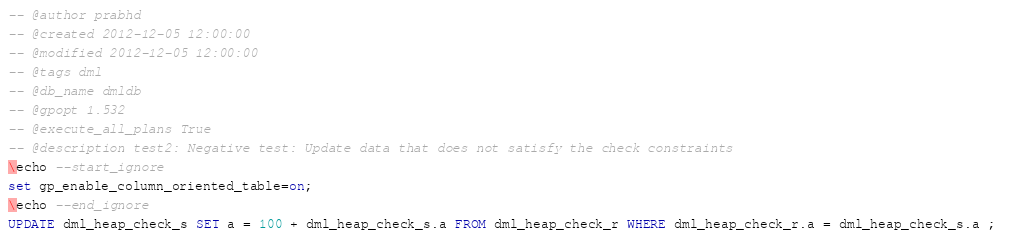Convert code to text. <code><loc_0><loc_0><loc_500><loc_500><_SQL_>-- @author prabhd 
-- @created 2012-12-05 12:00:00 
-- @modified 2012-12-05 12:00:00 
-- @tags dml 
-- @db_name dmldb
-- @gpopt 1.532
-- @execute_all_plans True
-- @description test2: Negative test: Update data that does not satisfy the check constraints 
\echo --start_ignore
set gp_enable_column_oriented_table=on;
\echo --end_ignore
UPDATE dml_heap_check_s SET a = 100 + dml_heap_check_s.a FROM dml_heap_check_r WHERE dml_heap_check_r.a = dml_heap_check_s.a ; 
</code> 